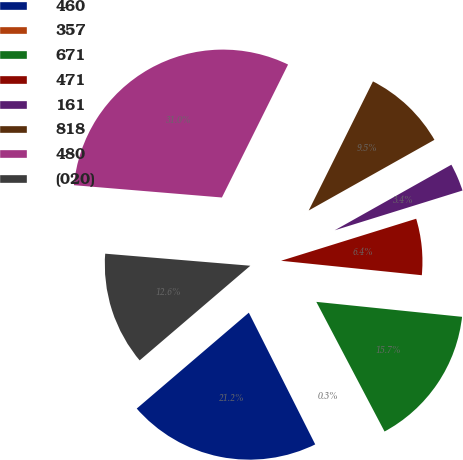Convert chart. <chart><loc_0><loc_0><loc_500><loc_500><pie_chart><fcel>460<fcel>357<fcel>671<fcel>471<fcel>161<fcel>818<fcel>480<fcel>(020)<nl><fcel>21.17%<fcel>0.28%<fcel>15.66%<fcel>6.43%<fcel>3.35%<fcel>9.5%<fcel>31.03%<fcel>12.58%<nl></chart> 